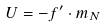<formula> <loc_0><loc_0><loc_500><loc_500>U = - f ^ { \prime } \cdot m _ { N }</formula> 